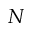Convert formula to latex. <formula><loc_0><loc_0><loc_500><loc_500>N</formula> 